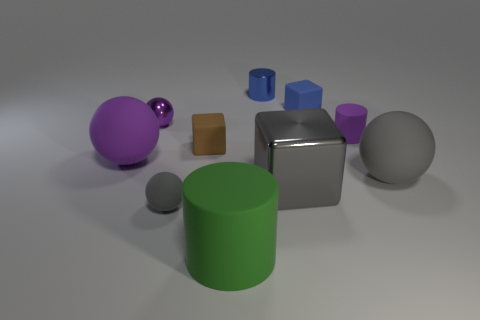There is a tiny matte thing that is the same color as the shiny cylinder; what shape is it?
Offer a very short reply. Cube. There is a large rubber object that is the same shape as the blue metal object; what color is it?
Your answer should be very brief. Green. What size is the other gray matte thing that is the same shape as the large gray rubber thing?
Keep it short and to the point. Small. How many other metallic spheres have the same color as the shiny sphere?
Your answer should be very brief. 0. There is a metallic object that is behind the brown cube and in front of the blue cylinder; what is its shape?
Your response must be concise. Sphere. What color is the object that is left of the big gray block and behind the tiny purple shiny thing?
Keep it short and to the point. Blue. Is the number of purple metal spheres in front of the tiny purple cylinder greater than the number of large green things that are to the right of the small blue metallic cylinder?
Offer a terse response. No. What is the color of the big matte ball that is right of the large green rubber cylinder?
Offer a very short reply. Gray. Does the big rubber object that is left of the green thing have the same shape as the gray thing to the right of the small purple cylinder?
Your answer should be compact. Yes. Are there any red metal cubes that have the same size as the blue cube?
Give a very brief answer. No. 